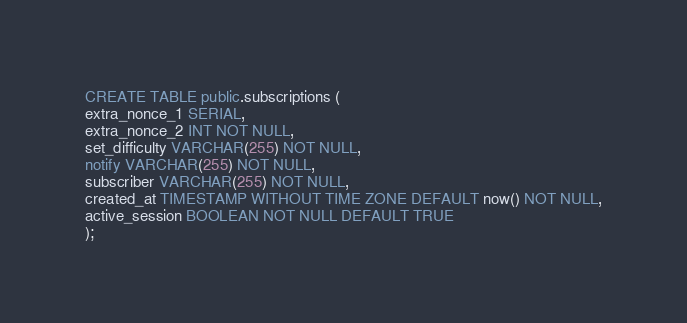Convert code to text. <code><loc_0><loc_0><loc_500><loc_500><_SQL_>CREATE TABLE public.subscriptions (
extra_nonce_1 SERIAL,
extra_nonce_2 INT NOT NULL,
set_difficulty VARCHAR(255) NOT NULL,
notify VARCHAR(255) NOT NULL,
subscriber VARCHAR(255) NOT NULL,
created_at TIMESTAMP WITHOUT TIME ZONE DEFAULT now() NOT NULL,
active_session BOOLEAN NOT NULL DEFAULT TRUE
);</code> 